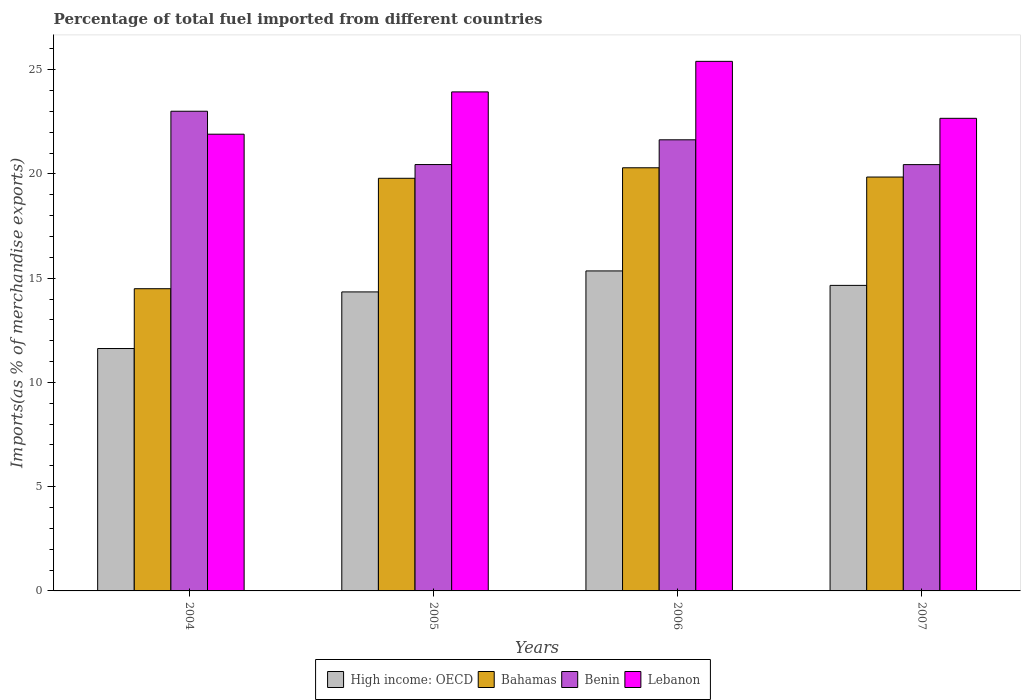How many groups of bars are there?
Your answer should be compact. 4. Are the number of bars per tick equal to the number of legend labels?
Your answer should be very brief. Yes. How many bars are there on the 2nd tick from the left?
Ensure brevity in your answer.  4. How many bars are there on the 2nd tick from the right?
Your answer should be very brief. 4. What is the percentage of imports to different countries in Lebanon in 2007?
Give a very brief answer. 22.67. Across all years, what is the maximum percentage of imports to different countries in Lebanon?
Your answer should be compact. 25.4. Across all years, what is the minimum percentage of imports to different countries in Benin?
Make the answer very short. 20.45. In which year was the percentage of imports to different countries in Benin maximum?
Offer a terse response. 2004. In which year was the percentage of imports to different countries in Bahamas minimum?
Give a very brief answer. 2004. What is the total percentage of imports to different countries in Lebanon in the graph?
Your response must be concise. 93.9. What is the difference between the percentage of imports to different countries in Lebanon in 2005 and that in 2006?
Make the answer very short. -1.46. What is the difference between the percentage of imports to different countries in Lebanon in 2006 and the percentage of imports to different countries in Benin in 2004?
Your answer should be compact. 2.39. What is the average percentage of imports to different countries in Lebanon per year?
Ensure brevity in your answer.  23.48. In the year 2007, what is the difference between the percentage of imports to different countries in High income: OECD and percentage of imports to different countries in Lebanon?
Keep it short and to the point. -8.01. In how many years, is the percentage of imports to different countries in Lebanon greater than 11 %?
Offer a very short reply. 4. What is the ratio of the percentage of imports to different countries in High income: OECD in 2005 to that in 2006?
Provide a short and direct response. 0.93. Is the percentage of imports to different countries in Benin in 2005 less than that in 2007?
Provide a short and direct response. No. Is the difference between the percentage of imports to different countries in High income: OECD in 2004 and 2007 greater than the difference between the percentage of imports to different countries in Lebanon in 2004 and 2007?
Your answer should be compact. No. What is the difference between the highest and the second highest percentage of imports to different countries in Bahamas?
Ensure brevity in your answer.  0.44. What is the difference between the highest and the lowest percentage of imports to different countries in Benin?
Make the answer very short. 2.56. What does the 3rd bar from the left in 2005 represents?
Make the answer very short. Benin. What does the 3rd bar from the right in 2005 represents?
Keep it short and to the point. Bahamas. How many bars are there?
Give a very brief answer. 16. Are all the bars in the graph horizontal?
Your answer should be compact. No. What is the difference between two consecutive major ticks on the Y-axis?
Provide a short and direct response. 5. Are the values on the major ticks of Y-axis written in scientific E-notation?
Your answer should be compact. No. Does the graph contain grids?
Make the answer very short. No. How many legend labels are there?
Your response must be concise. 4. What is the title of the graph?
Ensure brevity in your answer.  Percentage of total fuel imported from different countries. Does "Myanmar" appear as one of the legend labels in the graph?
Ensure brevity in your answer.  No. What is the label or title of the Y-axis?
Give a very brief answer. Imports(as % of merchandise exports). What is the Imports(as % of merchandise exports) of High income: OECD in 2004?
Give a very brief answer. 11.63. What is the Imports(as % of merchandise exports) in Bahamas in 2004?
Provide a succinct answer. 14.49. What is the Imports(as % of merchandise exports) in Benin in 2004?
Keep it short and to the point. 23.01. What is the Imports(as % of merchandise exports) of Lebanon in 2004?
Provide a succinct answer. 21.9. What is the Imports(as % of merchandise exports) in High income: OECD in 2005?
Give a very brief answer. 14.34. What is the Imports(as % of merchandise exports) in Bahamas in 2005?
Your response must be concise. 19.79. What is the Imports(as % of merchandise exports) of Benin in 2005?
Your answer should be compact. 20.45. What is the Imports(as % of merchandise exports) in Lebanon in 2005?
Your answer should be compact. 23.93. What is the Imports(as % of merchandise exports) in High income: OECD in 2006?
Offer a very short reply. 15.35. What is the Imports(as % of merchandise exports) of Bahamas in 2006?
Provide a short and direct response. 20.29. What is the Imports(as % of merchandise exports) in Benin in 2006?
Your answer should be very brief. 21.64. What is the Imports(as % of merchandise exports) in Lebanon in 2006?
Give a very brief answer. 25.4. What is the Imports(as % of merchandise exports) of High income: OECD in 2007?
Keep it short and to the point. 14.65. What is the Imports(as % of merchandise exports) of Bahamas in 2007?
Your response must be concise. 19.85. What is the Imports(as % of merchandise exports) of Benin in 2007?
Your answer should be very brief. 20.45. What is the Imports(as % of merchandise exports) in Lebanon in 2007?
Keep it short and to the point. 22.67. Across all years, what is the maximum Imports(as % of merchandise exports) in High income: OECD?
Your answer should be compact. 15.35. Across all years, what is the maximum Imports(as % of merchandise exports) in Bahamas?
Keep it short and to the point. 20.29. Across all years, what is the maximum Imports(as % of merchandise exports) of Benin?
Make the answer very short. 23.01. Across all years, what is the maximum Imports(as % of merchandise exports) of Lebanon?
Provide a succinct answer. 25.4. Across all years, what is the minimum Imports(as % of merchandise exports) of High income: OECD?
Your response must be concise. 11.63. Across all years, what is the minimum Imports(as % of merchandise exports) in Bahamas?
Your answer should be compact. 14.49. Across all years, what is the minimum Imports(as % of merchandise exports) of Benin?
Keep it short and to the point. 20.45. Across all years, what is the minimum Imports(as % of merchandise exports) of Lebanon?
Make the answer very short. 21.9. What is the total Imports(as % of merchandise exports) of High income: OECD in the graph?
Ensure brevity in your answer.  55.97. What is the total Imports(as % of merchandise exports) of Bahamas in the graph?
Give a very brief answer. 74.43. What is the total Imports(as % of merchandise exports) of Benin in the graph?
Keep it short and to the point. 85.54. What is the total Imports(as % of merchandise exports) of Lebanon in the graph?
Make the answer very short. 93.9. What is the difference between the Imports(as % of merchandise exports) of High income: OECD in 2004 and that in 2005?
Provide a short and direct response. -2.71. What is the difference between the Imports(as % of merchandise exports) in Bahamas in 2004 and that in 2005?
Ensure brevity in your answer.  -5.3. What is the difference between the Imports(as % of merchandise exports) of Benin in 2004 and that in 2005?
Offer a terse response. 2.56. What is the difference between the Imports(as % of merchandise exports) in Lebanon in 2004 and that in 2005?
Give a very brief answer. -2.03. What is the difference between the Imports(as % of merchandise exports) of High income: OECD in 2004 and that in 2006?
Provide a short and direct response. -3.72. What is the difference between the Imports(as % of merchandise exports) in Bahamas in 2004 and that in 2006?
Give a very brief answer. -5.8. What is the difference between the Imports(as % of merchandise exports) in Benin in 2004 and that in 2006?
Provide a succinct answer. 1.37. What is the difference between the Imports(as % of merchandise exports) of Lebanon in 2004 and that in 2006?
Your answer should be compact. -3.49. What is the difference between the Imports(as % of merchandise exports) in High income: OECD in 2004 and that in 2007?
Your answer should be very brief. -3.03. What is the difference between the Imports(as % of merchandise exports) in Bahamas in 2004 and that in 2007?
Offer a terse response. -5.36. What is the difference between the Imports(as % of merchandise exports) of Benin in 2004 and that in 2007?
Ensure brevity in your answer.  2.56. What is the difference between the Imports(as % of merchandise exports) in Lebanon in 2004 and that in 2007?
Ensure brevity in your answer.  -0.76. What is the difference between the Imports(as % of merchandise exports) in High income: OECD in 2005 and that in 2006?
Your answer should be very brief. -1.01. What is the difference between the Imports(as % of merchandise exports) in Bahamas in 2005 and that in 2006?
Provide a succinct answer. -0.5. What is the difference between the Imports(as % of merchandise exports) in Benin in 2005 and that in 2006?
Give a very brief answer. -1.19. What is the difference between the Imports(as % of merchandise exports) of Lebanon in 2005 and that in 2006?
Keep it short and to the point. -1.46. What is the difference between the Imports(as % of merchandise exports) in High income: OECD in 2005 and that in 2007?
Keep it short and to the point. -0.31. What is the difference between the Imports(as % of merchandise exports) in Bahamas in 2005 and that in 2007?
Offer a terse response. -0.06. What is the difference between the Imports(as % of merchandise exports) of Benin in 2005 and that in 2007?
Offer a very short reply. 0. What is the difference between the Imports(as % of merchandise exports) of Lebanon in 2005 and that in 2007?
Ensure brevity in your answer.  1.27. What is the difference between the Imports(as % of merchandise exports) of High income: OECD in 2006 and that in 2007?
Provide a short and direct response. 0.69. What is the difference between the Imports(as % of merchandise exports) of Bahamas in 2006 and that in 2007?
Make the answer very short. 0.44. What is the difference between the Imports(as % of merchandise exports) in Benin in 2006 and that in 2007?
Offer a terse response. 1.19. What is the difference between the Imports(as % of merchandise exports) in Lebanon in 2006 and that in 2007?
Give a very brief answer. 2.73. What is the difference between the Imports(as % of merchandise exports) of High income: OECD in 2004 and the Imports(as % of merchandise exports) of Bahamas in 2005?
Make the answer very short. -8.16. What is the difference between the Imports(as % of merchandise exports) of High income: OECD in 2004 and the Imports(as % of merchandise exports) of Benin in 2005?
Offer a very short reply. -8.82. What is the difference between the Imports(as % of merchandise exports) in High income: OECD in 2004 and the Imports(as % of merchandise exports) in Lebanon in 2005?
Your answer should be compact. -12.31. What is the difference between the Imports(as % of merchandise exports) in Bahamas in 2004 and the Imports(as % of merchandise exports) in Benin in 2005?
Give a very brief answer. -5.95. What is the difference between the Imports(as % of merchandise exports) in Bahamas in 2004 and the Imports(as % of merchandise exports) in Lebanon in 2005?
Keep it short and to the point. -9.44. What is the difference between the Imports(as % of merchandise exports) in Benin in 2004 and the Imports(as % of merchandise exports) in Lebanon in 2005?
Offer a terse response. -0.93. What is the difference between the Imports(as % of merchandise exports) in High income: OECD in 2004 and the Imports(as % of merchandise exports) in Bahamas in 2006?
Your answer should be very brief. -8.67. What is the difference between the Imports(as % of merchandise exports) of High income: OECD in 2004 and the Imports(as % of merchandise exports) of Benin in 2006?
Ensure brevity in your answer.  -10.01. What is the difference between the Imports(as % of merchandise exports) of High income: OECD in 2004 and the Imports(as % of merchandise exports) of Lebanon in 2006?
Keep it short and to the point. -13.77. What is the difference between the Imports(as % of merchandise exports) of Bahamas in 2004 and the Imports(as % of merchandise exports) of Benin in 2006?
Your answer should be very brief. -7.14. What is the difference between the Imports(as % of merchandise exports) in Bahamas in 2004 and the Imports(as % of merchandise exports) in Lebanon in 2006?
Offer a very short reply. -10.9. What is the difference between the Imports(as % of merchandise exports) of Benin in 2004 and the Imports(as % of merchandise exports) of Lebanon in 2006?
Your answer should be compact. -2.39. What is the difference between the Imports(as % of merchandise exports) in High income: OECD in 2004 and the Imports(as % of merchandise exports) in Bahamas in 2007?
Keep it short and to the point. -8.22. What is the difference between the Imports(as % of merchandise exports) of High income: OECD in 2004 and the Imports(as % of merchandise exports) of Benin in 2007?
Make the answer very short. -8.82. What is the difference between the Imports(as % of merchandise exports) of High income: OECD in 2004 and the Imports(as % of merchandise exports) of Lebanon in 2007?
Your answer should be very brief. -11.04. What is the difference between the Imports(as % of merchandise exports) in Bahamas in 2004 and the Imports(as % of merchandise exports) in Benin in 2007?
Your answer should be very brief. -5.95. What is the difference between the Imports(as % of merchandise exports) in Bahamas in 2004 and the Imports(as % of merchandise exports) in Lebanon in 2007?
Your response must be concise. -8.17. What is the difference between the Imports(as % of merchandise exports) in Benin in 2004 and the Imports(as % of merchandise exports) in Lebanon in 2007?
Keep it short and to the point. 0.34. What is the difference between the Imports(as % of merchandise exports) of High income: OECD in 2005 and the Imports(as % of merchandise exports) of Bahamas in 2006?
Provide a succinct answer. -5.95. What is the difference between the Imports(as % of merchandise exports) of High income: OECD in 2005 and the Imports(as % of merchandise exports) of Benin in 2006?
Give a very brief answer. -7.29. What is the difference between the Imports(as % of merchandise exports) in High income: OECD in 2005 and the Imports(as % of merchandise exports) in Lebanon in 2006?
Offer a terse response. -11.06. What is the difference between the Imports(as % of merchandise exports) in Bahamas in 2005 and the Imports(as % of merchandise exports) in Benin in 2006?
Your answer should be very brief. -1.85. What is the difference between the Imports(as % of merchandise exports) of Bahamas in 2005 and the Imports(as % of merchandise exports) of Lebanon in 2006?
Give a very brief answer. -5.61. What is the difference between the Imports(as % of merchandise exports) of Benin in 2005 and the Imports(as % of merchandise exports) of Lebanon in 2006?
Your response must be concise. -4.95. What is the difference between the Imports(as % of merchandise exports) of High income: OECD in 2005 and the Imports(as % of merchandise exports) of Bahamas in 2007?
Provide a short and direct response. -5.51. What is the difference between the Imports(as % of merchandise exports) of High income: OECD in 2005 and the Imports(as % of merchandise exports) of Benin in 2007?
Your response must be concise. -6.1. What is the difference between the Imports(as % of merchandise exports) in High income: OECD in 2005 and the Imports(as % of merchandise exports) in Lebanon in 2007?
Provide a succinct answer. -8.33. What is the difference between the Imports(as % of merchandise exports) in Bahamas in 2005 and the Imports(as % of merchandise exports) in Benin in 2007?
Your answer should be compact. -0.66. What is the difference between the Imports(as % of merchandise exports) in Bahamas in 2005 and the Imports(as % of merchandise exports) in Lebanon in 2007?
Ensure brevity in your answer.  -2.88. What is the difference between the Imports(as % of merchandise exports) in Benin in 2005 and the Imports(as % of merchandise exports) in Lebanon in 2007?
Your answer should be very brief. -2.22. What is the difference between the Imports(as % of merchandise exports) of High income: OECD in 2006 and the Imports(as % of merchandise exports) of Bahamas in 2007?
Your response must be concise. -4.5. What is the difference between the Imports(as % of merchandise exports) in High income: OECD in 2006 and the Imports(as % of merchandise exports) in Benin in 2007?
Your answer should be very brief. -5.1. What is the difference between the Imports(as % of merchandise exports) of High income: OECD in 2006 and the Imports(as % of merchandise exports) of Lebanon in 2007?
Give a very brief answer. -7.32. What is the difference between the Imports(as % of merchandise exports) of Bahamas in 2006 and the Imports(as % of merchandise exports) of Benin in 2007?
Your response must be concise. -0.15. What is the difference between the Imports(as % of merchandise exports) in Bahamas in 2006 and the Imports(as % of merchandise exports) in Lebanon in 2007?
Offer a very short reply. -2.37. What is the difference between the Imports(as % of merchandise exports) in Benin in 2006 and the Imports(as % of merchandise exports) in Lebanon in 2007?
Offer a terse response. -1.03. What is the average Imports(as % of merchandise exports) in High income: OECD per year?
Offer a very short reply. 13.99. What is the average Imports(as % of merchandise exports) of Bahamas per year?
Make the answer very short. 18.61. What is the average Imports(as % of merchandise exports) in Benin per year?
Offer a terse response. 21.38. What is the average Imports(as % of merchandise exports) in Lebanon per year?
Offer a terse response. 23.48. In the year 2004, what is the difference between the Imports(as % of merchandise exports) in High income: OECD and Imports(as % of merchandise exports) in Bahamas?
Your answer should be compact. -2.87. In the year 2004, what is the difference between the Imports(as % of merchandise exports) in High income: OECD and Imports(as % of merchandise exports) in Benin?
Provide a short and direct response. -11.38. In the year 2004, what is the difference between the Imports(as % of merchandise exports) in High income: OECD and Imports(as % of merchandise exports) in Lebanon?
Offer a terse response. -10.28. In the year 2004, what is the difference between the Imports(as % of merchandise exports) of Bahamas and Imports(as % of merchandise exports) of Benin?
Ensure brevity in your answer.  -8.51. In the year 2004, what is the difference between the Imports(as % of merchandise exports) of Bahamas and Imports(as % of merchandise exports) of Lebanon?
Provide a short and direct response. -7.41. In the year 2004, what is the difference between the Imports(as % of merchandise exports) of Benin and Imports(as % of merchandise exports) of Lebanon?
Give a very brief answer. 1.1. In the year 2005, what is the difference between the Imports(as % of merchandise exports) of High income: OECD and Imports(as % of merchandise exports) of Bahamas?
Ensure brevity in your answer.  -5.45. In the year 2005, what is the difference between the Imports(as % of merchandise exports) of High income: OECD and Imports(as % of merchandise exports) of Benin?
Give a very brief answer. -6.11. In the year 2005, what is the difference between the Imports(as % of merchandise exports) of High income: OECD and Imports(as % of merchandise exports) of Lebanon?
Give a very brief answer. -9.59. In the year 2005, what is the difference between the Imports(as % of merchandise exports) of Bahamas and Imports(as % of merchandise exports) of Benin?
Provide a short and direct response. -0.66. In the year 2005, what is the difference between the Imports(as % of merchandise exports) in Bahamas and Imports(as % of merchandise exports) in Lebanon?
Give a very brief answer. -4.14. In the year 2005, what is the difference between the Imports(as % of merchandise exports) in Benin and Imports(as % of merchandise exports) in Lebanon?
Your answer should be compact. -3.48. In the year 2006, what is the difference between the Imports(as % of merchandise exports) of High income: OECD and Imports(as % of merchandise exports) of Bahamas?
Keep it short and to the point. -4.95. In the year 2006, what is the difference between the Imports(as % of merchandise exports) of High income: OECD and Imports(as % of merchandise exports) of Benin?
Ensure brevity in your answer.  -6.29. In the year 2006, what is the difference between the Imports(as % of merchandise exports) in High income: OECD and Imports(as % of merchandise exports) in Lebanon?
Offer a very short reply. -10.05. In the year 2006, what is the difference between the Imports(as % of merchandise exports) in Bahamas and Imports(as % of merchandise exports) in Benin?
Keep it short and to the point. -1.34. In the year 2006, what is the difference between the Imports(as % of merchandise exports) in Bahamas and Imports(as % of merchandise exports) in Lebanon?
Keep it short and to the point. -5.1. In the year 2006, what is the difference between the Imports(as % of merchandise exports) in Benin and Imports(as % of merchandise exports) in Lebanon?
Your answer should be very brief. -3.76. In the year 2007, what is the difference between the Imports(as % of merchandise exports) in High income: OECD and Imports(as % of merchandise exports) in Bahamas?
Your response must be concise. -5.2. In the year 2007, what is the difference between the Imports(as % of merchandise exports) of High income: OECD and Imports(as % of merchandise exports) of Benin?
Provide a succinct answer. -5.79. In the year 2007, what is the difference between the Imports(as % of merchandise exports) in High income: OECD and Imports(as % of merchandise exports) in Lebanon?
Offer a very short reply. -8.01. In the year 2007, what is the difference between the Imports(as % of merchandise exports) in Bahamas and Imports(as % of merchandise exports) in Benin?
Your answer should be very brief. -0.6. In the year 2007, what is the difference between the Imports(as % of merchandise exports) of Bahamas and Imports(as % of merchandise exports) of Lebanon?
Provide a succinct answer. -2.82. In the year 2007, what is the difference between the Imports(as % of merchandise exports) of Benin and Imports(as % of merchandise exports) of Lebanon?
Keep it short and to the point. -2.22. What is the ratio of the Imports(as % of merchandise exports) of High income: OECD in 2004 to that in 2005?
Your answer should be very brief. 0.81. What is the ratio of the Imports(as % of merchandise exports) in Bahamas in 2004 to that in 2005?
Ensure brevity in your answer.  0.73. What is the ratio of the Imports(as % of merchandise exports) of Benin in 2004 to that in 2005?
Your answer should be very brief. 1.12. What is the ratio of the Imports(as % of merchandise exports) in Lebanon in 2004 to that in 2005?
Keep it short and to the point. 0.92. What is the ratio of the Imports(as % of merchandise exports) of High income: OECD in 2004 to that in 2006?
Your response must be concise. 0.76. What is the ratio of the Imports(as % of merchandise exports) of Bahamas in 2004 to that in 2006?
Your answer should be compact. 0.71. What is the ratio of the Imports(as % of merchandise exports) of Benin in 2004 to that in 2006?
Offer a very short reply. 1.06. What is the ratio of the Imports(as % of merchandise exports) in Lebanon in 2004 to that in 2006?
Your answer should be compact. 0.86. What is the ratio of the Imports(as % of merchandise exports) of High income: OECD in 2004 to that in 2007?
Offer a very short reply. 0.79. What is the ratio of the Imports(as % of merchandise exports) in Bahamas in 2004 to that in 2007?
Ensure brevity in your answer.  0.73. What is the ratio of the Imports(as % of merchandise exports) in Benin in 2004 to that in 2007?
Offer a terse response. 1.13. What is the ratio of the Imports(as % of merchandise exports) in Lebanon in 2004 to that in 2007?
Keep it short and to the point. 0.97. What is the ratio of the Imports(as % of merchandise exports) of High income: OECD in 2005 to that in 2006?
Your response must be concise. 0.93. What is the ratio of the Imports(as % of merchandise exports) of Bahamas in 2005 to that in 2006?
Provide a succinct answer. 0.98. What is the ratio of the Imports(as % of merchandise exports) in Benin in 2005 to that in 2006?
Your response must be concise. 0.95. What is the ratio of the Imports(as % of merchandise exports) of Lebanon in 2005 to that in 2006?
Your response must be concise. 0.94. What is the ratio of the Imports(as % of merchandise exports) of High income: OECD in 2005 to that in 2007?
Your answer should be compact. 0.98. What is the ratio of the Imports(as % of merchandise exports) of Bahamas in 2005 to that in 2007?
Your answer should be compact. 1. What is the ratio of the Imports(as % of merchandise exports) in Benin in 2005 to that in 2007?
Offer a terse response. 1. What is the ratio of the Imports(as % of merchandise exports) in Lebanon in 2005 to that in 2007?
Your answer should be compact. 1.06. What is the ratio of the Imports(as % of merchandise exports) in High income: OECD in 2006 to that in 2007?
Give a very brief answer. 1.05. What is the ratio of the Imports(as % of merchandise exports) in Bahamas in 2006 to that in 2007?
Give a very brief answer. 1.02. What is the ratio of the Imports(as % of merchandise exports) of Benin in 2006 to that in 2007?
Make the answer very short. 1.06. What is the ratio of the Imports(as % of merchandise exports) in Lebanon in 2006 to that in 2007?
Offer a terse response. 1.12. What is the difference between the highest and the second highest Imports(as % of merchandise exports) of High income: OECD?
Keep it short and to the point. 0.69. What is the difference between the highest and the second highest Imports(as % of merchandise exports) of Bahamas?
Provide a short and direct response. 0.44. What is the difference between the highest and the second highest Imports(as % of merchandise exports) of Benin?
Make the answer very short. 1.37. What is the difference between the highest and the second highest Imports(as % of merchandise exports) in Lebanon?
Your answer should be very brief. 1.46. What is the difference between the highest and the lowest Imports(as % of merchandise exports) of High income: OECD?
Give a very brief answer. 3.72. What is the difference between the highest and the lowest Imports(as % of merchandise exports) in Bahamas?
Give a very brief answer. 5.8. What is the difference between the highest and the lowest Imports(as % of merchandise exports) of Benin?
Provide a succinct answer. 2.56. What is the difference between the highest and the lowest Imports(as % of merchandise exports) in Lebanon?
Offer a terse response. 3.49. 